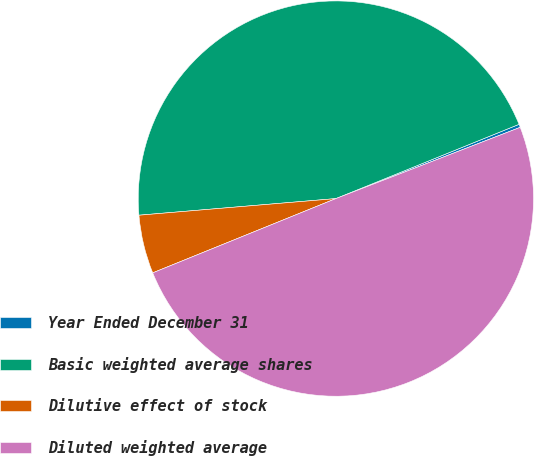Convert chart to OTSL. <chart><loc_0><loc_0><loc_500><loc_500><pie_chart><fcel>Year Ended December 31<fcel>Basic weighted average shares<fcel>Dilutive effect of stock<fcel>Diluted weighted average<nl><fcel>0.26%<fcel>45.21%<fcel>4.79%<fcel>49.74%<nl></chart> 